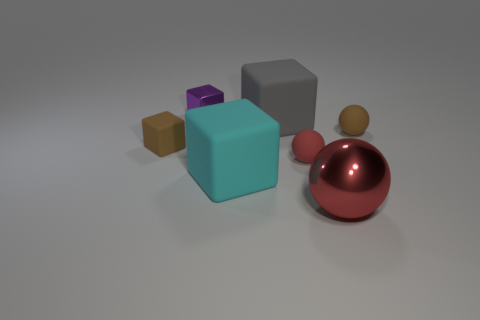What material is the brown object that is on the left side of the tiny purple object left of the large sphere? rubber 